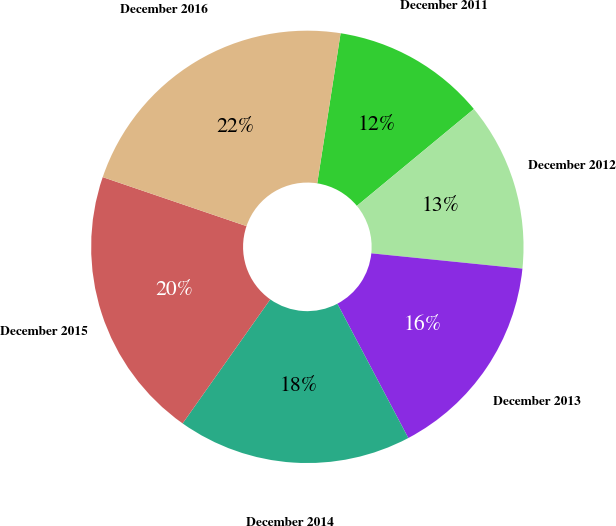<chart> <loc_0><loc_0><loc_500><loc_500><pie_chart><fcel>December 2011<fcel>December 2012<fcel>December 2013<fcel>December 2014<fcel>December 2015<fcel>December 2016<nl><fcel>11.54%<fcel>12.61%<fcel>15.66%<fcel>17.52%<fcel>20.44%<fcel>22.23%<nl></chart> 